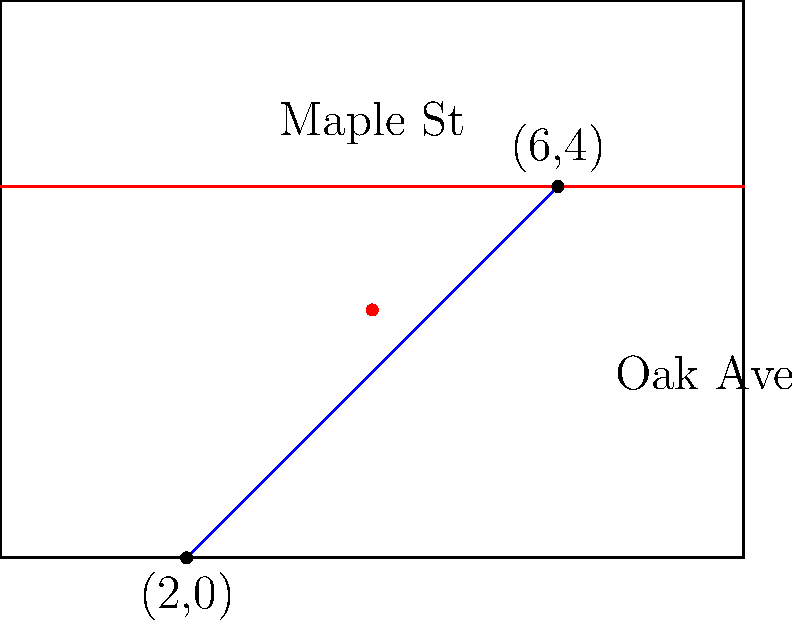As the property manager of a neighborhood, you're tasked with finding the intersection point of Maple Street and Oak Avenue. Maple Street runs horizontally and can be represented by the equation $y = 4$. Oak Avenue can be represented by the line passing through points $(2,0)$ and $(6,4)$. What are the coordinates of the intersection point? To find the intersection point, we need to follow these steps:

1) First, let's find the equation of Oak Avenue using the point-slope form:
   
   $y - y_1 = m(x - x_1)$, where $m$ is the slope.

2) Calculate the slope of Oak Avenue:
   $m = \frac{y_2 - y_1}{x_2 - x_1} = \frac{4 - 0}{6 - 2} = \frac{4}{4} = 1$

3) Use point $(2,0)$ to form the equation:
   $y - 0 = 1(x - 2)$
   $y = x - 2$

4) Now we have two equations:
   Maple Street: $y = 4$
   Oak Avenue: $y = x - 2$

5) At the intersection point, both equations are true. So, we can set them equal:
   $4 = x - 2$

6) Solve for $x$:
   $x = 6$

7) To find $y$, we can use either equation. Let's use Maple Street's equation:
   $y = 4$

Therefore, the intersection point is $(6,4)$.
Answer: $(6,4)$ 